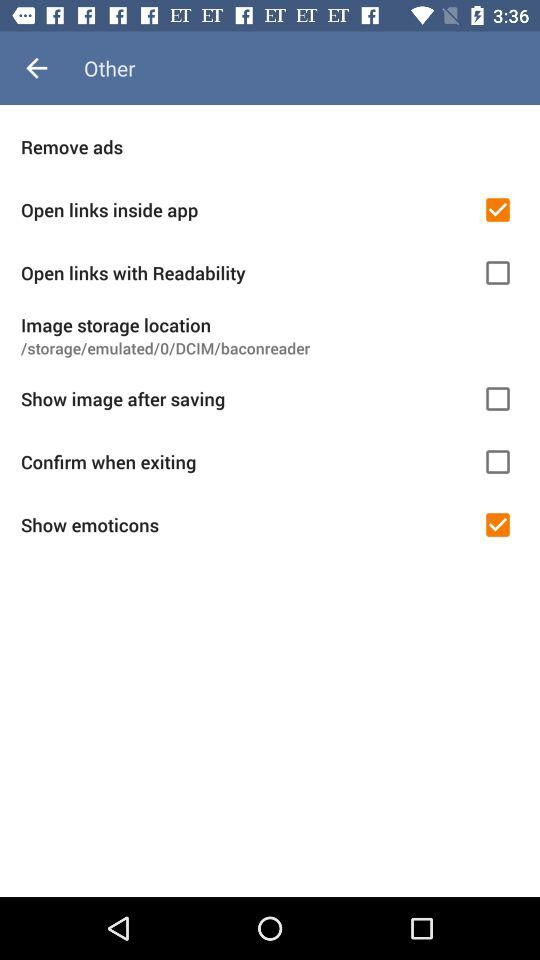How many items have checkboxes?
Answer the question using a single word or phrase. 5 